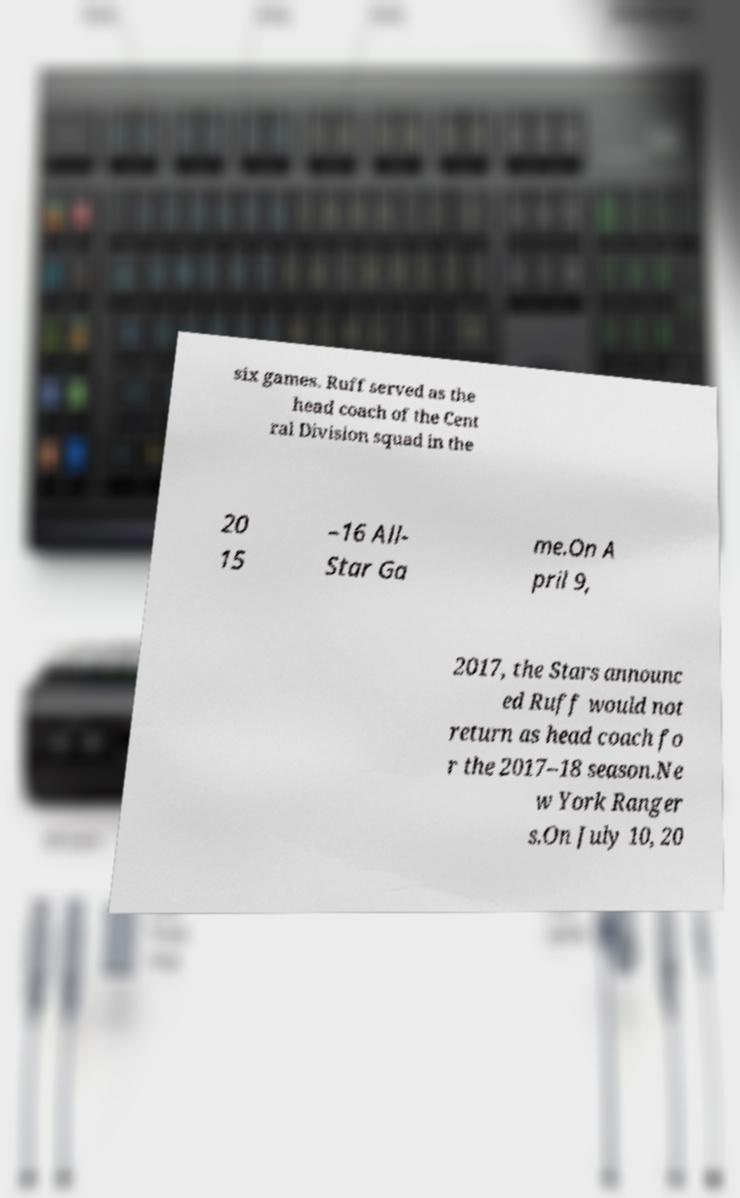What messages or text are displayed in this image? I need them in a readable, typed format. six games. Ruff served as the head coach of the Cent ral Division squad in the 20 15 –16 All- Star Ga me.On A pril 9, 2017, the Stars announc ed Ruff would not return as head coach fo r the 2017–18 season.Ne w York Ranger s.On July 10, 20 